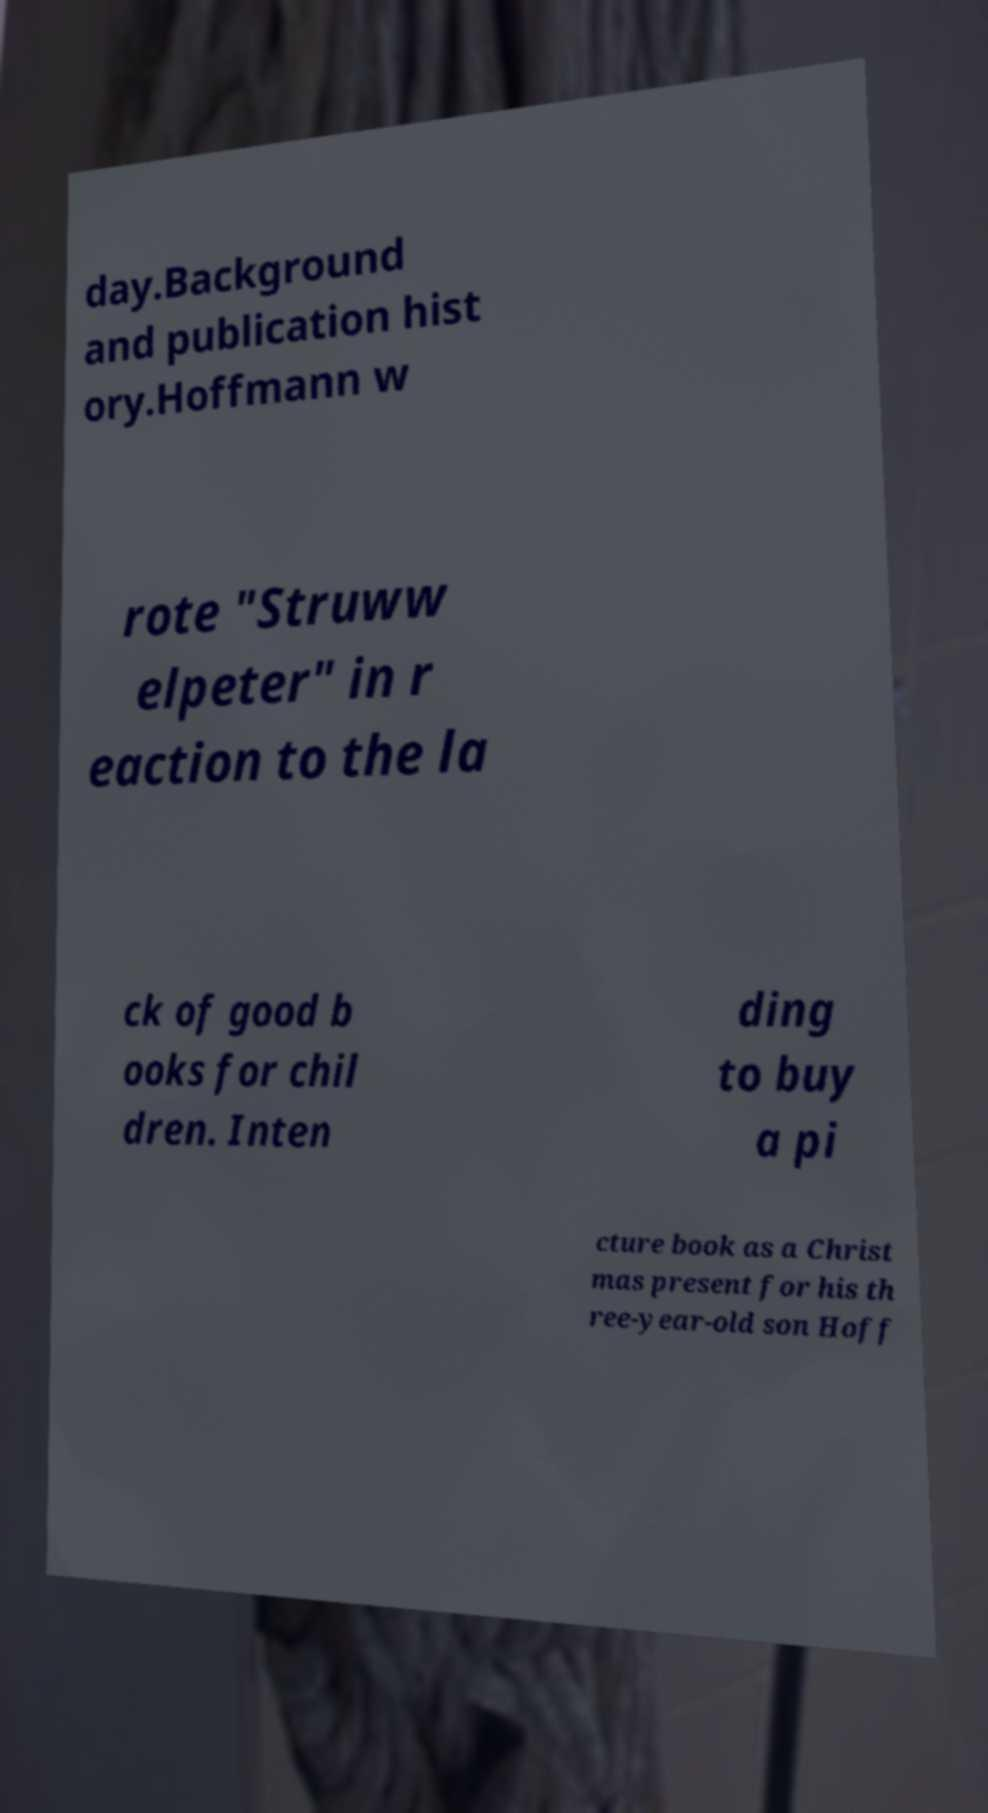Can you accurately transcribe the text from the provided image for me? day.Background and publication hist ory.Hoffmann w rote "Struww elpeter" in r eaction to the la ck of good b ooks for chil dren. Inten ding to buy a pi cture book as a Christ mas present for his th ree-year-old son Hoff 